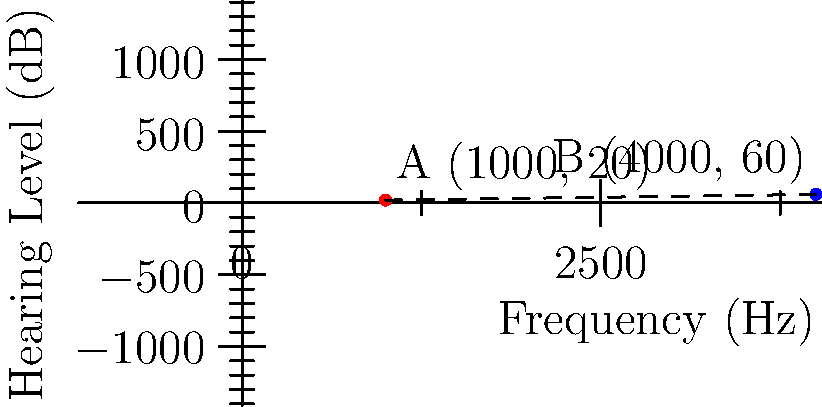In an audiogram, two significant points are identified: point A at (1000 Hz, 20 dB) and point B at (4000 Hz, 60 dB). Calculate the distance between these two points, representing the change in both frequency and hearing level. Round your answer to the nearest whole number. To find the distance between two points in a coordinate plane, we can use the distance formula:

$$ d = \sqrt{(x_2 - x_1)^2 + (y_2 - y_1)^2} $$

Where $(x_1, y_1)$ is the first point and $(x_2, y_2)$ is the second point.

Step 1: Identify the coordinates
Point A: $(x_1, y_1) = (1000, 20)$
Point B: $(x_2, y_2) = (4000, 60)$

Step 2: Plug the values into the distance formula
$$ d = \sqrt{(4000 - 1000)^2 + (60 - 20)^2} $$

Step 3: Simplify
$$ d = \sqrt{3000^2 + 40^2} $$
$$ d = \sqrt{9,000,000 + 1,600} $$
$$ d = \sqrt{9,001,600} $$

Step 4: Calculate and round to the nearest whole number
$$ d \approx 3000.27 $$

Rounded to the nearest whole number: 3000
Answer: 3000 